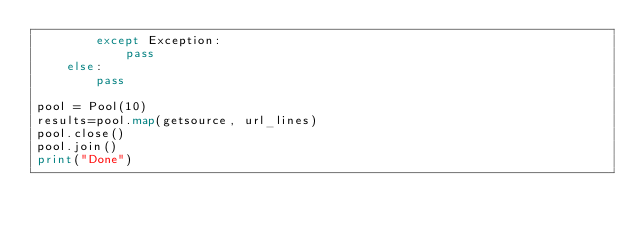Convert code to text. <code><loc_0><loc_0><loc_500><loc_500><_Python_>        except Exception:
            pass
    else:
        pass

pool = Pool(10)
results=pool.map(getsource, url_lines)
pool.close()
pool.join()
print("Done")
</code> 